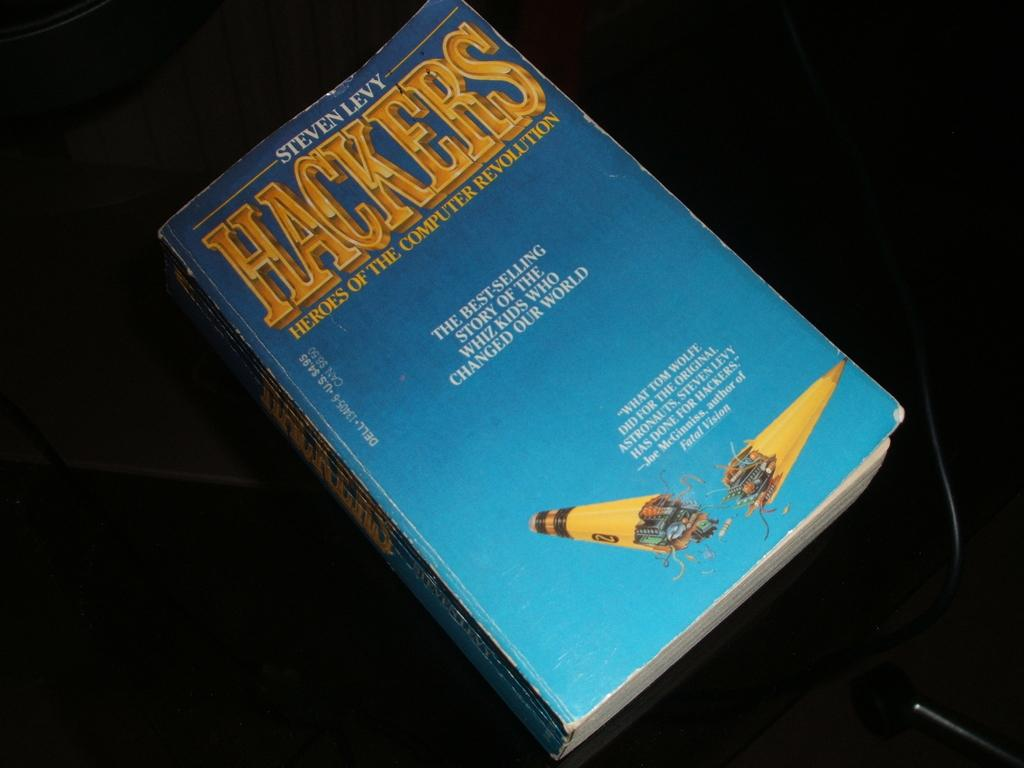<image>
Describe the image concisely. Hackers by Steven Levy with a broken pencil on the front cover. 